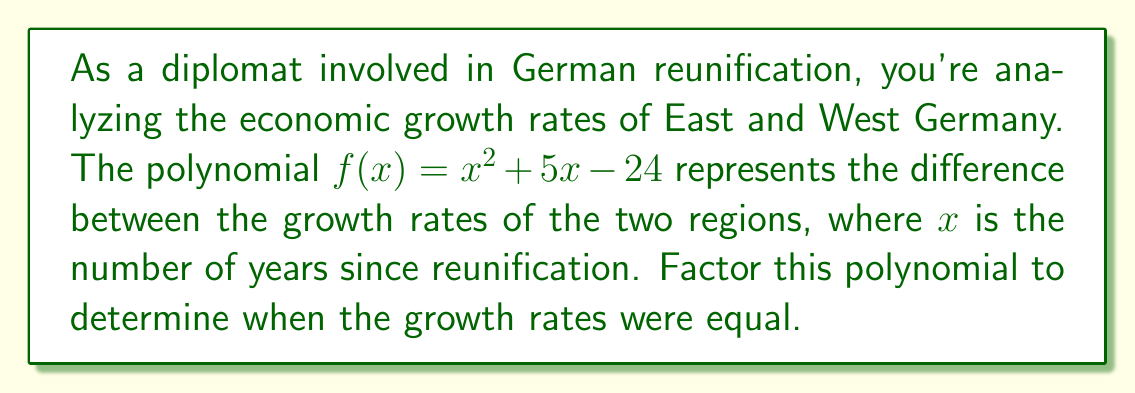Show me your answer to this math problem. To factor the polynomial $f(x) = x^2 + 5x - 24$, we'll use the following steps:

1) First, we identify that this is a quadratic polynomial in the form $ax^2 + bx + c$, where $a=1$, $b=5$, and $c=-24$.

2) We'll use the factoring method by finding two numbers that multiply to give $ac$ and add up to $b$.

3) $ac = 1 \times (-24) = -24$
   We need to find two numbers that multiply to give -24 and add up to 5.

4) The factors of -24 are: ±1, ±2, ±3, ±4, ±6, ±8, ±12, ±24
   By inspection, we can see that 8 and -3 satisfy our conditions:
   $8 \times (-3) = -24$ and $8 + (-3) = 5$

5) We can now rewrite the middle term:
   $f(x) = x^2 + 8x - 3x - 24$

6) Grouping the terms:
   $f(x) = (x^2 + 8x) + (-3x - 24)$

7) Factoring out the common factors from each group:
   $f(x) = x(x + 8) - 3(x + 8)$

8) Factoring out the common binomial:
   $f(x) = (x - 3)(x + 8)$

Therefore, the factored form of the polynomial is $(x - 3)(x + 8)$. The growth rates were equal when $f(x) = 0$, which occurs when $x = 3$ or $x = -8$. Since $x$ represents years after reunification, the relevant solution is $x = 3$, meaning the growth rates were equal 3 years after reunification.
Answer: $(x - 3)(x + 8)$ 